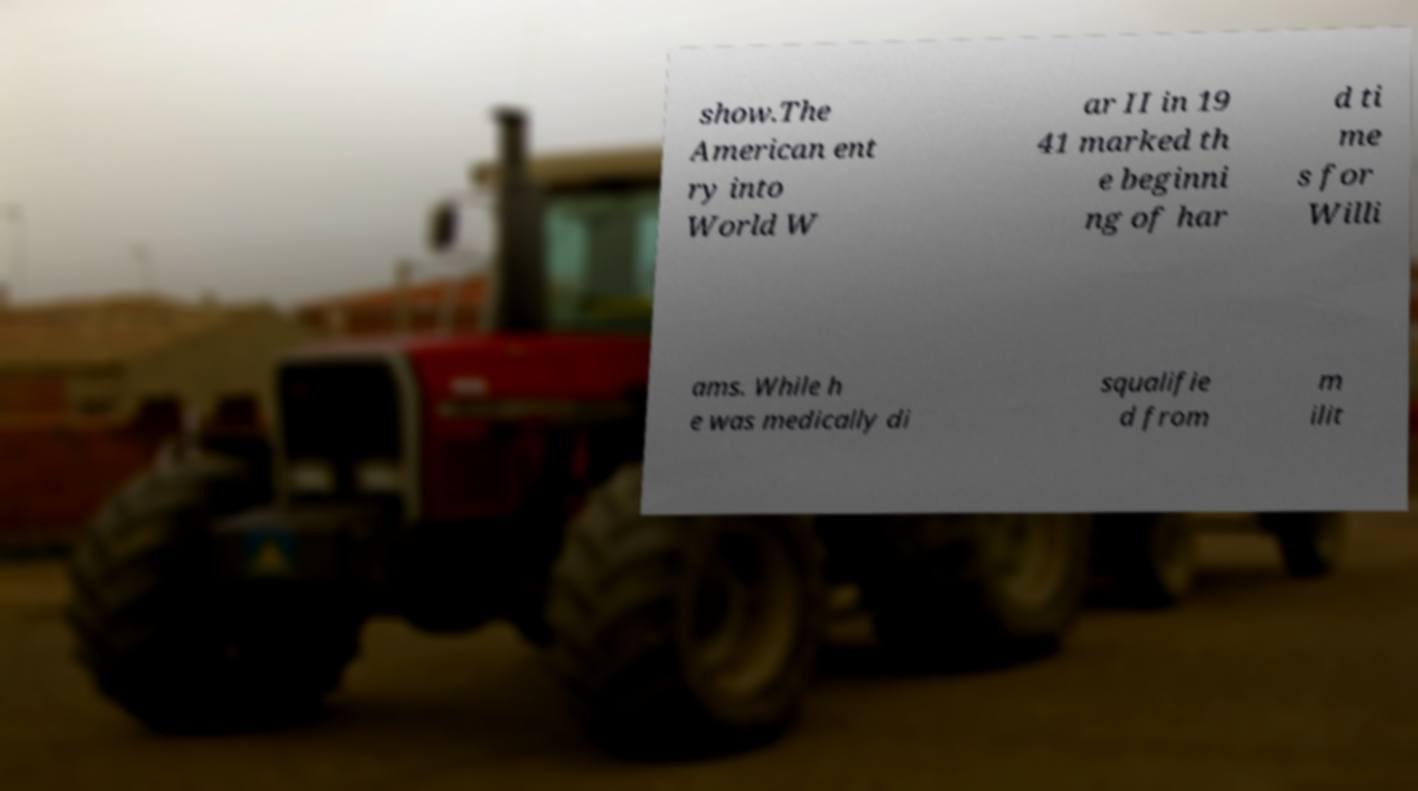Could you assist in decoding the text presented in this image and type it out clearly? show.The American ent ry into World W ar II in 19 41 marked th e beginni ng of har d ti me s for Willi ams. While h e was medically di squalifie d from m ilit 